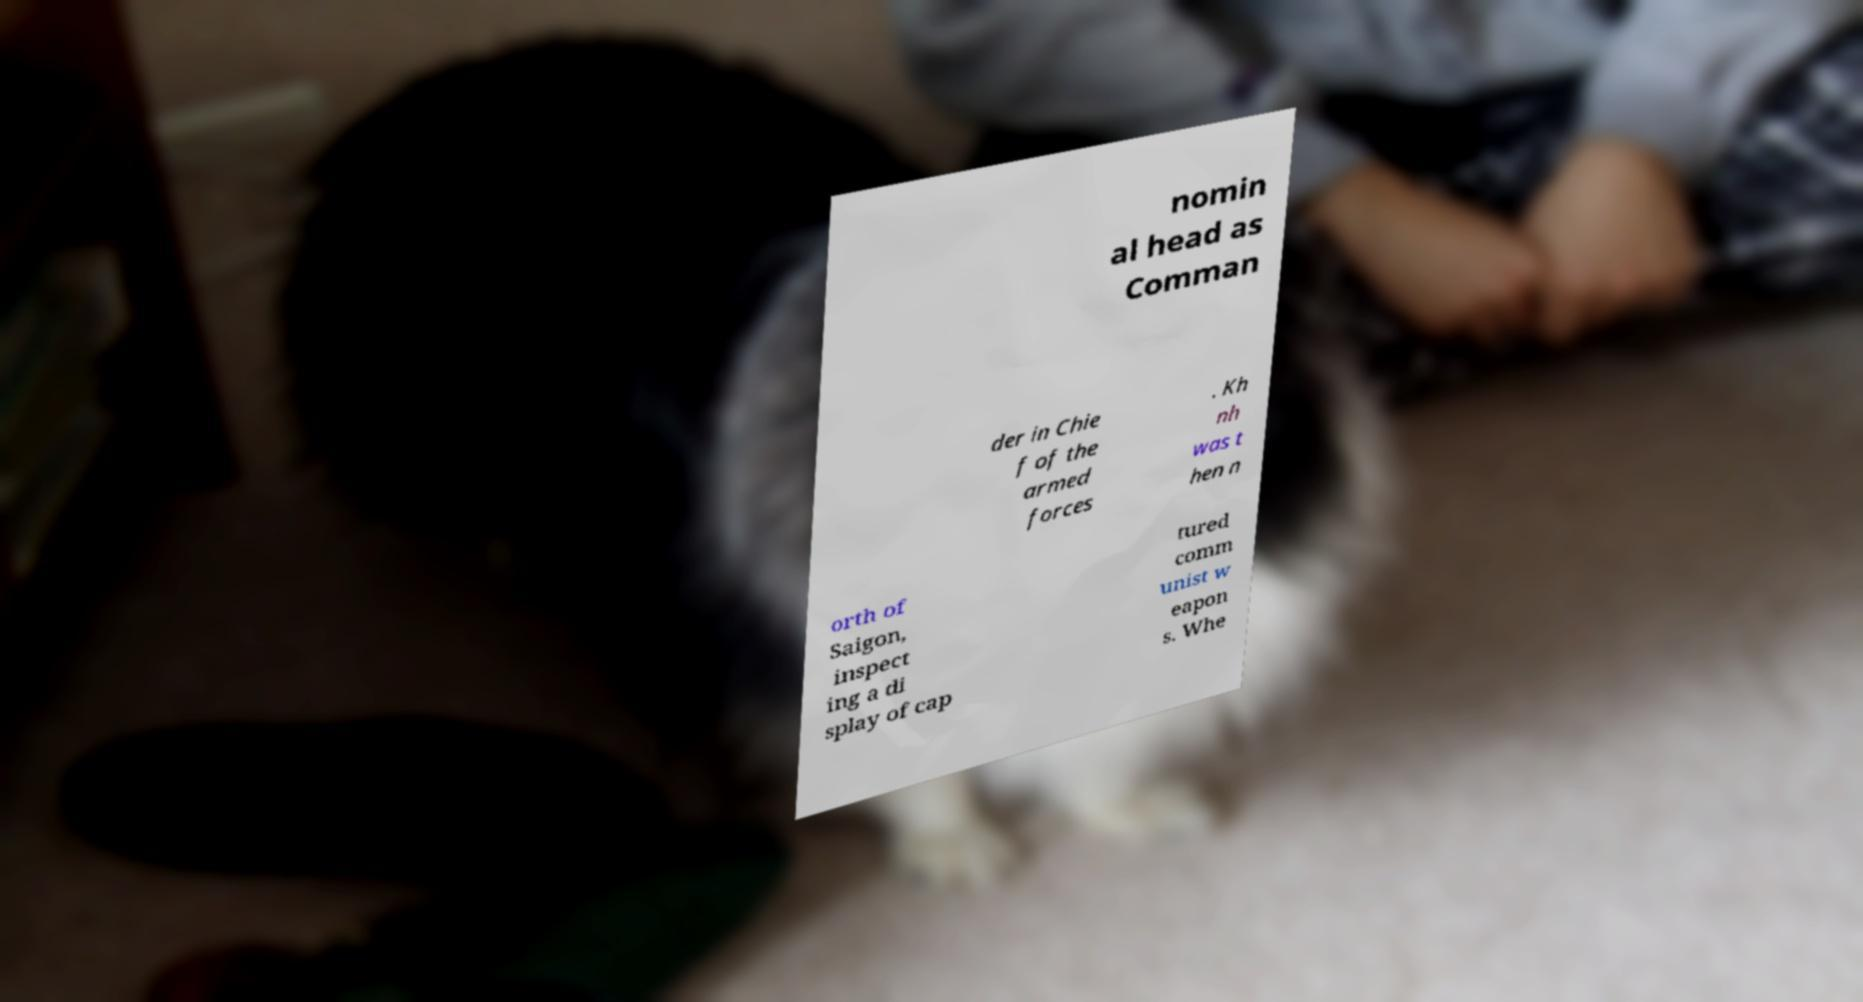Please identify and transcribe the text found in this image. nomin al head as Comman der in Chie f of the armed forces . Kh nh was t hen n orth of Saigon, inspect ing a di splay of cap tured comm unist w eapon s. Whe 